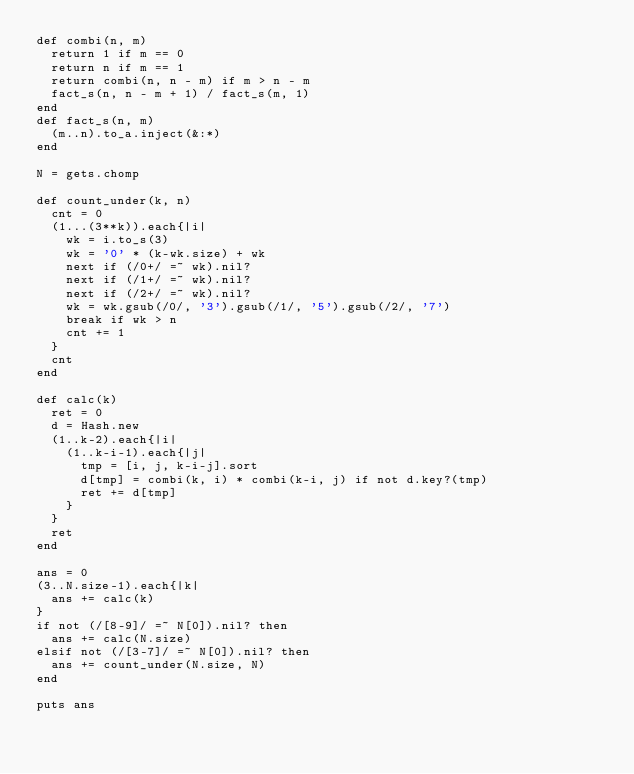Convert code to text. <code><loc_0><loc_0><loc_500><loc_500><_Ruby_>def combi(n, m)
  return 1 if m == 0
  return n if m == 1
  return combi(n, n - m) if m > n - m
  fact_s(n, n - m + 1) / fact_s(m, 1)
end
def fact_s(n, m)
  (m..n).to_a.inject(&:*)
end

N = gets.chomp

def count_under(k, n)
  cnt = 0
  (1...(3**k)).each{|i|
    wk = i.to_s(3)
    wk = '0' * (k-wk.size) + wk
    next if (/0+/ =~ wk).nil?
    next if (/1+/ =~ wk).nil?
    next if (/2+/ =~ wk).nil?
    wk = wk.gsub(/0/, '3').gsub(/1/, '5').gsub(/2/, '7')
    break if wk > n
    cnt += 1
  }
  cnt
end

def calc(k)
  ret = 0
  d = Hash.new
  (1..k-2).each{|i|
    (1..k-i-1).each{|j|
      tmp = [i, j, k-i-j].sort
      d[tmp] = combi(k, i) * combi(k-i, j) if not d.key?(tmp)
      ret += d[tmp]
    }
  }
  ret
end

ans = 0
(3..N.size-1).each{|k|
  ans += calc(k)
}
if not (/[8-9]/ =~ N[0]).nil? then
  ans += calc(N.size)
elsif not (/[3-7]/ =~ N[0]).nil? then
  ans += count_under(N.size, N)
end

puts ans
</code> 